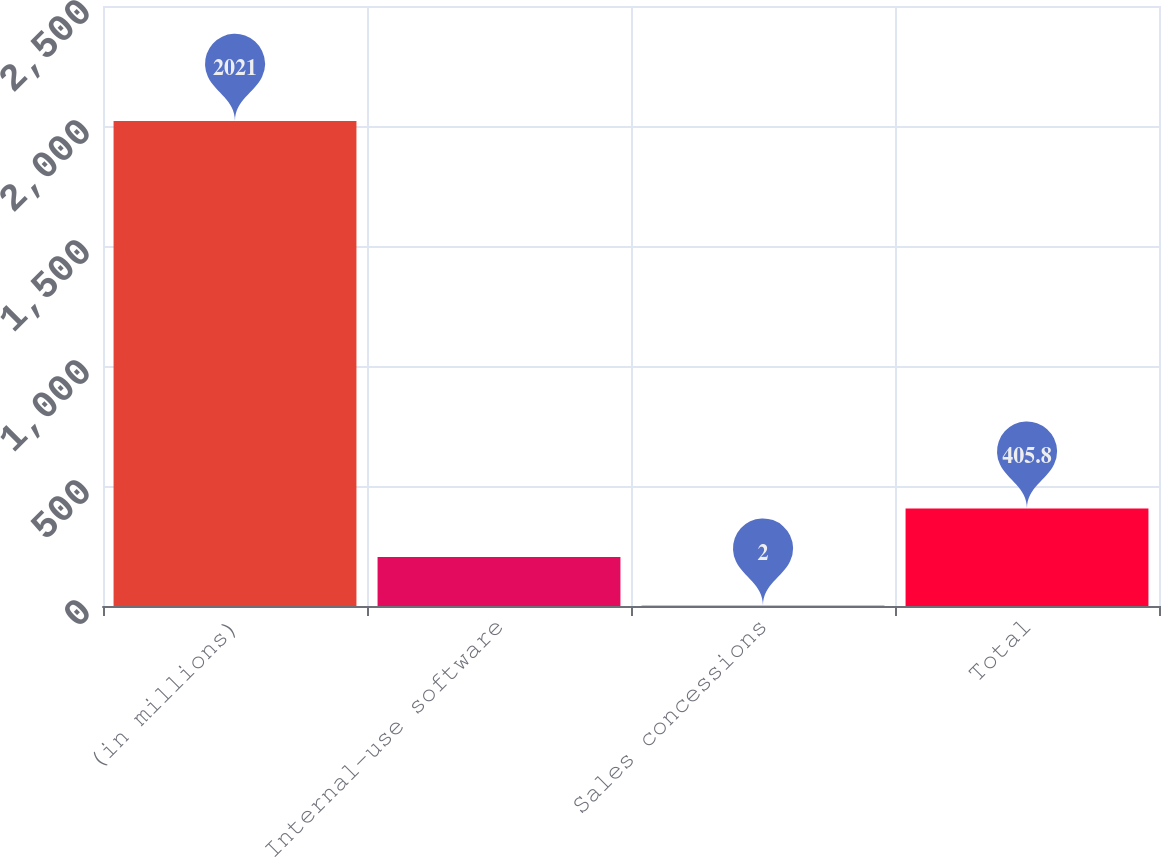Convert chart to OTSL. <chart><loc_0><loc_0><loc_500><loc_500><bar_chart><fcel>(in millions)<fcel>Internal-use software<fcel>Sales concessions<fcel>Total<nl><fcel>2021<fcel>203.9<fcel>2<fcel>405.8<nl></chart> 